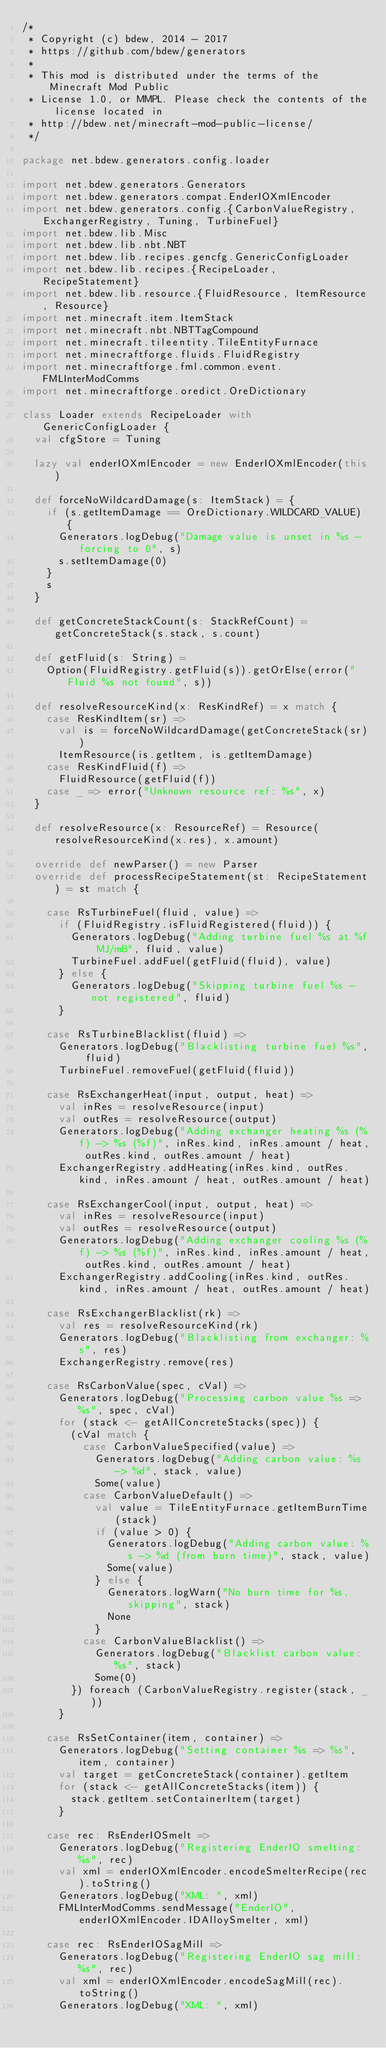Convert code to text. <code><loc_0><loc_0><loc_500><loc_500><_Scala_>/*
 * Copyright (c) bdew, 2014 - 2017
 * https://github.com/bdew/generators
 *
 * This mod is distributed under the terms of the Minecraft Mod Public
 * License 1.0, or MMPL. Please check the contents of the license located in
 * http://bdew.net/minecraft-mod-public-license/
 */

package net.bdew.generators.config.loader

import net.bdew.generators.Generators
import net.bdew.generators.compat.EnderIOXmlEncoder
import net.bdew.generators.config.{CarbonValueRegistry, ExchangerRegistry, Tuning, TurbineFuel}
import net.bdew.lib.Misc
import net.bdew.lib.nbt.NBT
import net.bdew.lib.recipes.gencfg.GenericConfigLoader
import net.bdew.lib.recipes.{RecipeLoader, RecipeStatement}
import net.bdew.lib.resource.{FluidResource, ItemResource, Resource}
import net.minecraft.item.ItemStack
import net.minecraft.nbt.NBTTagCompound
import net.minecraft.tileentity.TileEntityFurnace
import net.minecraftforge.fluids.FluidRegistry
import net.minecraftforge.fml.common.event.FMLInterModComms
import net.minecraftforge.oredict.OreDictionary

class Loader extends RecipeLoader with GenericConfigLoader {
  val cfgStore = Tuning

  lazy val enderIOXmlEncoder = new EnderIOXmlEncoder(this)

  def forceNoWildcardDamage(s: ItemStack) = {
    if (s.getItemDamage == OreDictionary.WILDCARD_VALUE) {
      Generators.logDebug("Damage value is unset in %s - forcing to 0", s)
      s.setItemDamage(0)
    }
    s
  }

  def getConcreteStackCount(s: StackRefCount) = getConcreteStack(s.stack, s.count)

  def getFluid(s: String) =
    Option(FluidRegistry.getFluid(s)).getOrElse(error("Fluid %s not found", s))

  def resolveResourceKind(x: ResKindRef) = x match {
    case ResKindItem(sr) =>
      val is = forceNoWildcardDamage(getConcreteStack(sr))
      ItemResource(is.getItem, is.getItemDamage)
    case ResKindFluid(f) =>
      FluidResource(getFluid(f))
    case _ => error("Unknown resource ref: %s", x)
  }

  def resolveResource(x: ResourceRef) = Resource(resolveResourceKind(x.res), x.amount)

  override def newParser() = new Parser
  override def processRecipeStatement(st: RecipeStatement) = st match {

    case RsTurbineFuel(fluid, value) =>
      if (FluidRegistry.isFluidRegistered(fluid)) {
        Generators.logDebug("Adding turbine fuel %s at %f MJ/mB", fluid, value)
        TurbineFuel.addFuel(getFluid(fluid), value)
      } else {
        Generators.logDebug("Skipping turbine fuel %s - not registered", fluid)
      }

    case RsTurbineBlacklist(fluid) =>
      Generators.logDebug("Blacklisting turbine fuel %s", fluid)
      TurbineFuel.removeFuel(getFluid(fluid))

    case RsExchangerHeat(input, output, heat) =>
      val inRes = resolveResource(input)
      val outRes = resolveResource(output)
      Generators.logDebug("Adding exchanger heating %s (%f) -> %s (%f)", inRes.kind, inRes.amount / heat, outRes.kind, outRes.amount / heat)
      ExchangerRegistry.addHeating(inRes.kind, outRes.kind, inRes.amount / heat, outRes.amount / heat)

    case RsExchangerCool(input, output, heat) =>
      val inRes = resolveResource(input)
      val outRes = resolveResource(output)
      Generators.logDebug("Adding exchanger cooling %s (%f) -> %s (%f)", inRes.kind, inRes.amount / heat, outRes.kind, outRes.amount / heat)
      ExchangerRegistry.addCooling(inRes.kind, outRes.kind, inRes.amount / heat, outRes.amount / heat)

    case RsExchangerBlacklist(rk) =>
      val res = resolveResourceKind(rk)
      Generators.logDebug("Blacklisting from exchanger: %s", res)
      ExchangerRegistry.remove(res)

    case RsCarbonValue(spec, cVal) =>
      Generators.logDebug("Processing carbon value %s => %s", spec, cVal)
      for (stack <- getAllConcreteStacks(spec)) {
        (cVal match {
          case CarbonValueSpecified(value) =>
            Generators.logDebug("Adding carbon value: %s -> %d", stack, value)
            Some(value)
          case CarbonValueDefault() =>
            val value = TileEntityFurnace.getItemBurnTime(stack)
            if (value > 0) {
              Generators.logDebug("Adding carbon value: %s -> %d (from burn time)", stack, value)
              Some(value)
            } else {
              Generators.logWarn("No burn time for %s, skipping", stack)
              None
            }
          case CarbonValueBlacklist() =>
            Generators.logDebug("Blacklist carbon value: %s", stack)
            Some(0)
        }) foreach (CarbonValueRegistry.register(stack, _))
      }

    case RsSetContainer(item, container) =>
      Generators.logDebug("Setting container %s => %s", item, container)
      val target = getConcreteStack(container).getItem
      for (stack <- getAllConcreteStacks(item)) {
        stack.getItem.setContainerItem(target)
      }

    case rec: RsEnderIOSmelt =>
      Generators.logDebug("Registering EnderIO smelting: %s", rec)
      val xml = enderIOXmlEncoder.encodeSmelterRecipe(rec).toString()
      Generators.logDebug("XML: ", xml)
      FMLInterModComms.sendMessage("EnderIO", enderIOXmlEncoder.IDAlloySmelter, xml)

    case rec: RsEnderIOSagMill =>
      Generators.logDebug("Registering EnderIO sag mill: %s", rec)
      val xml = enderIOXmlEncoder.encodeSagMill(rec).toString()
      Generators.logDebug("XML: ", xml)</code> 